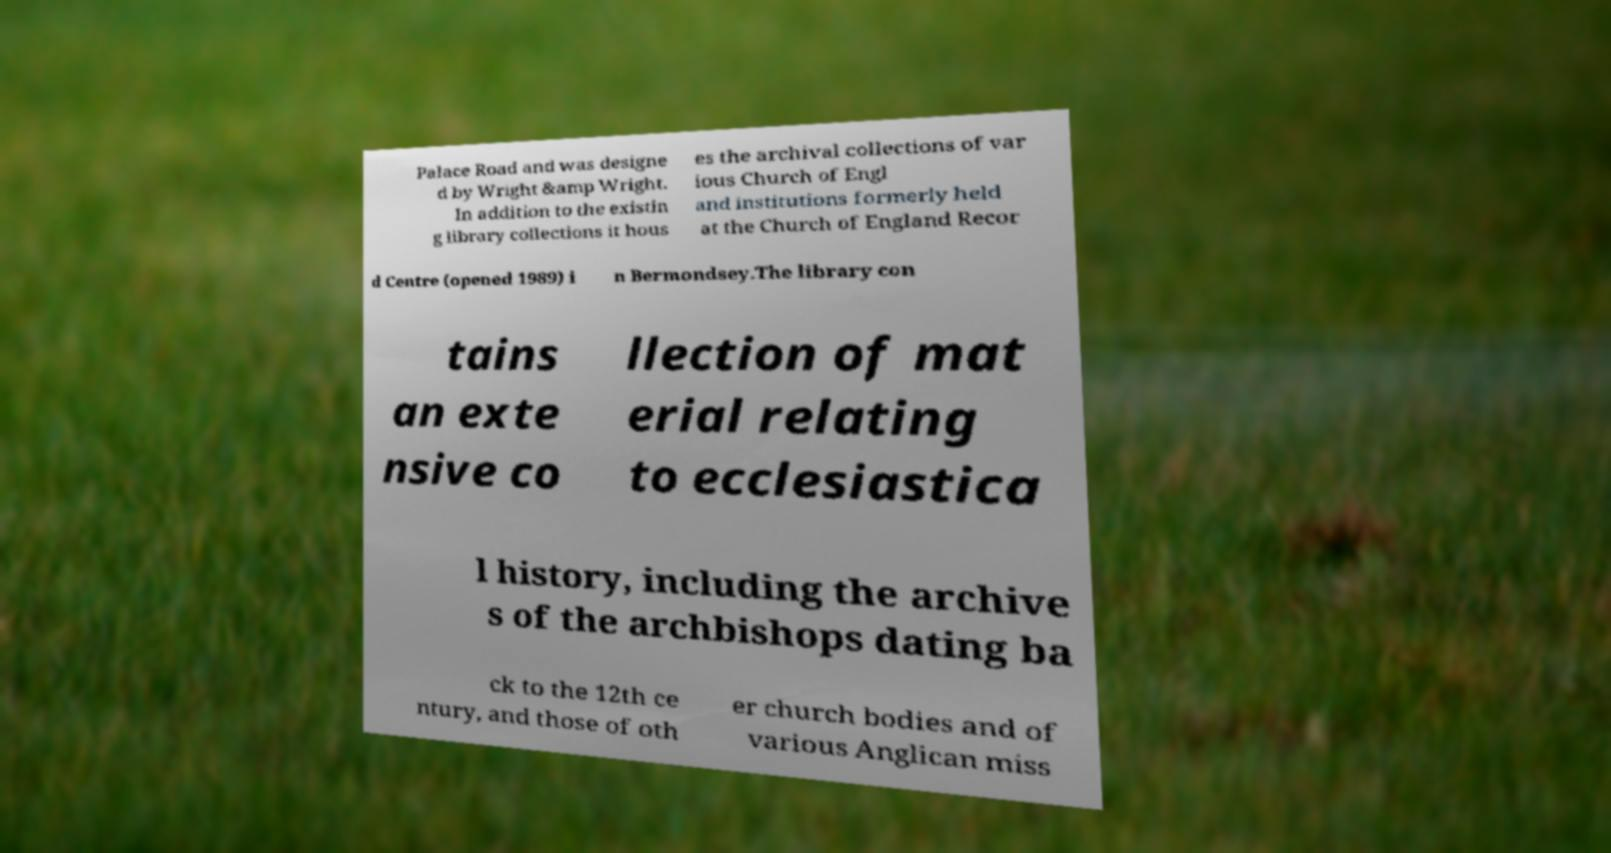There's text embedded in this image that I need extracted. Can you transcribe it verbatim? Palace Road and was designe d by Wright &amp Wright. In addition to the existin g library collections it hous es the archival collections of var ious Church of Engl and institutions formerly held at the Church of England Recor d Centre (opened 1989) i n Bermondsey.The library con tains an exte nsive co llection of mat erial relating to ecclesiastica l history, including the archive s of the archbishops dating ba ck to the 12th ce ntury, and those of oth er church bodies and of various Anglican miss 